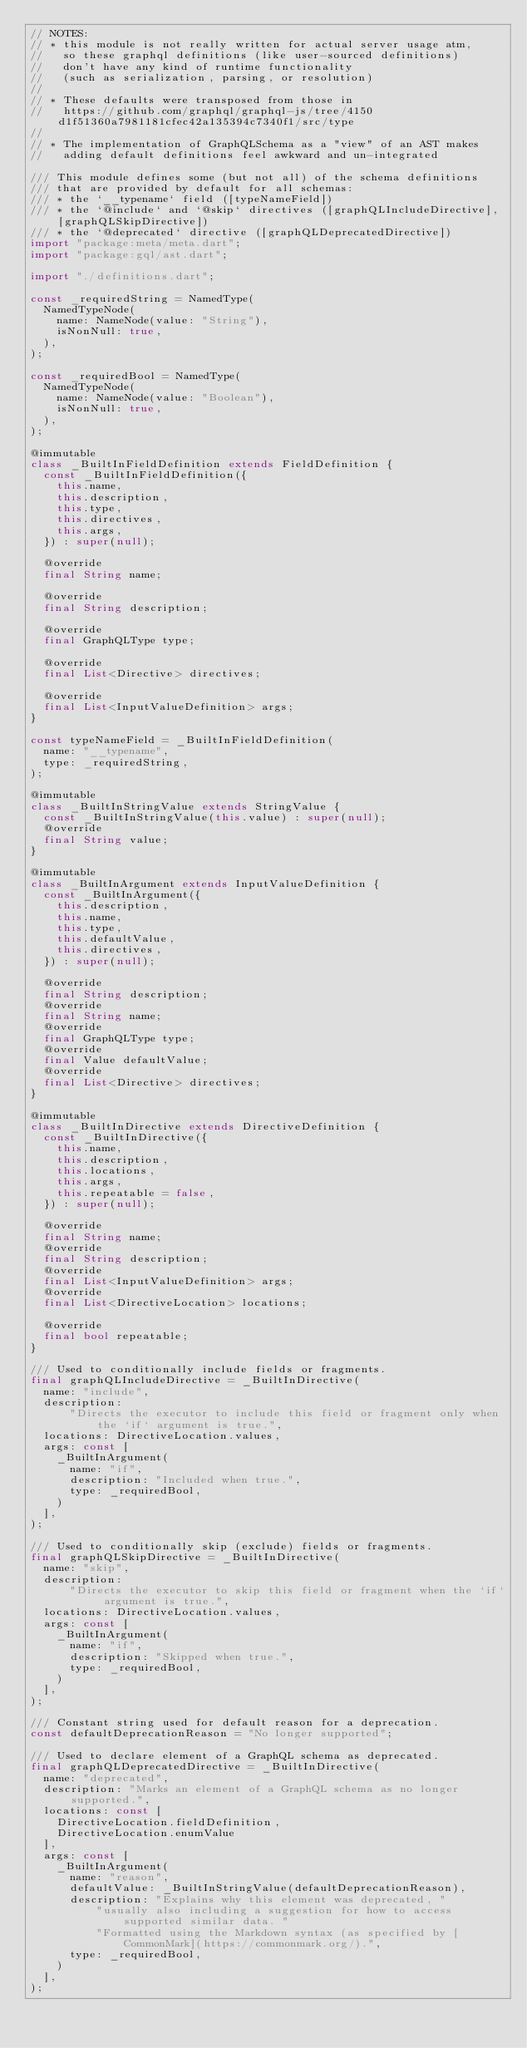Convert code to text. <code><loc_0><loc_0><loc_500><loc_500><_Dart_>// NOTES:
// * this module is not really written for actual server usage atm,
//   so these graphql definitions (like user-sourced definitions)
//   don't have any kind of runtime functionality
//   (such as serialization, parsing, or resolution)
//
// * These defaults were transposed from those in
//   https://github.com/graphql/graphql-js/tree/4150d1f51360a7981181cfec42a135394c7340f1/src/type
//
// * The implementation of GraphQLSchema as a "view" of an AST makes
//   adding default definitions feel awkward and un-integrated

/// This module defines some (but not all) of the schema definitions
/// that are provided by default for all schemas:
/// * the `__typename` field ([typeNameField])
/// * the `@include` and `@skip` directives ([graphQLIncludeDirective], [graphQLSkipDirective])
/// * the `@deprecated` directive ([graphQLDeprecatedDirective])
import "package:meta/meta.dart";
import "package:gql/ast.dart";

import "./definitions.dart";

const _requiredString = NamedType(
  NamedTypeNode(
    name: NameNode(value: "String"),
    isNonNull: true,
  ),
);

const _requiredBool = NamedType(
  NamedTypeNode(
    name: NameNode(value: "Boolean"),
    isNonNull: true,
  ),
);

@immutable
class _BuiltInFieldDefinition extends FieldDefinition {
  const _BuiltInFieldDefinition({
    this.name,
    this.description,
    this.type,
    this.directives,
    this.args,
  }) : super(null);

  @override
  final String name;

  @override
  final String description;

  @override
  final GraphQLType type;

  @override
  final List<Directive> directives;

  @override
  final List<InputValueDefinition> args;
}

const typeNameField = _BuiltInFieldDefinition(
  name: "__typename",
  type: _requiredString,
);

@immutable
class _BuiltInStringValue extends StringValue {
  const _BuiltInStringValue(this.value) : super(null);
  @override
  final String value;
}

@immutable
class _BuiltInArgument extends InputValueDefinition {
  const _BuiltInArgument({
    this.description,
    this.name,
    this.type,
    this.defaultValue,
    this.directives,
  }) : super(null);

  @override
  final String description;
  @override
  final String name;
  @override
  final GraphQLType type;
  @override
  final Value defaultValue;
  @override
  final List<Directive> directives;
}

@immutable
class _BuiltInDirective extends DirectiveDefinition {
  const _BuiltInDirective({
    this.name,
    this.description,
    this.locations,
    this.args,
    this.repeatable = false,
  }) : super(null);

  @override
  final String name;
  @override
  final String description;
  @override
  final List<InputValueDefinition> args;
  @override
  final List<DirectiveLocation> locations;

  @override
  final bool repeatable;
}

/// Used to conditionally include fields or fragments.
final graphQLIncludeDirective = _BuiltInDirective(
  name: "include",
  description:
      "Directs the executor to include this field or fragment only when the `if` argument is true.",
  locations: DirectiveLocation.values,
  args: const [
    _BuiltInArgument(
      name: "if",
      description: "Included when true.",
      type: _requiredBool,
    )
  ],
);

/// Used to conditionally skip (exclude) fields or fragments.
final graphQLSkipDirective = _BuiltInDirective(
  name: "skip",
  description:
      "Directs the executor to skip this field or fragment when the `if` argument is true.",
  locations: DirectiveLocation.values,
  args: const [
    _BuiltInArgument(
      name: "if",
      description: "Skipped when true.",
      type: _requiredBool,
    )
  ],
);

/// Constant string used for default reason for a deprecation.
const defaultDeprecationReason = "No longer supported";

/// Used to declare element of a GraphQL schema as deprecated.
final graphQLDeprecatedDirective = _BuiltInDirective(
  name: "deprecated",
  description: "Marks an element of a GraphQL schema as no longer supported.",
  locations: const [
    DirectiveLocation.fieldDefinition,
    DirectiveLocation.enumValue
  ],
  args: const [
    _BuiltInArgument(
      name: "reason",
      defaultValue: _BuiltInStringValue(defaultDeprecationReason),
      description: "Explains why this element was deprecated, "
          "usually also including a suggestion for how to access supported similar data. "
          "Formatted using the Markdown syntax (as specified by [CommonMark](https://commonmark.org/).",
      type: _requiredBool,
    )
  ],
);
</code> 